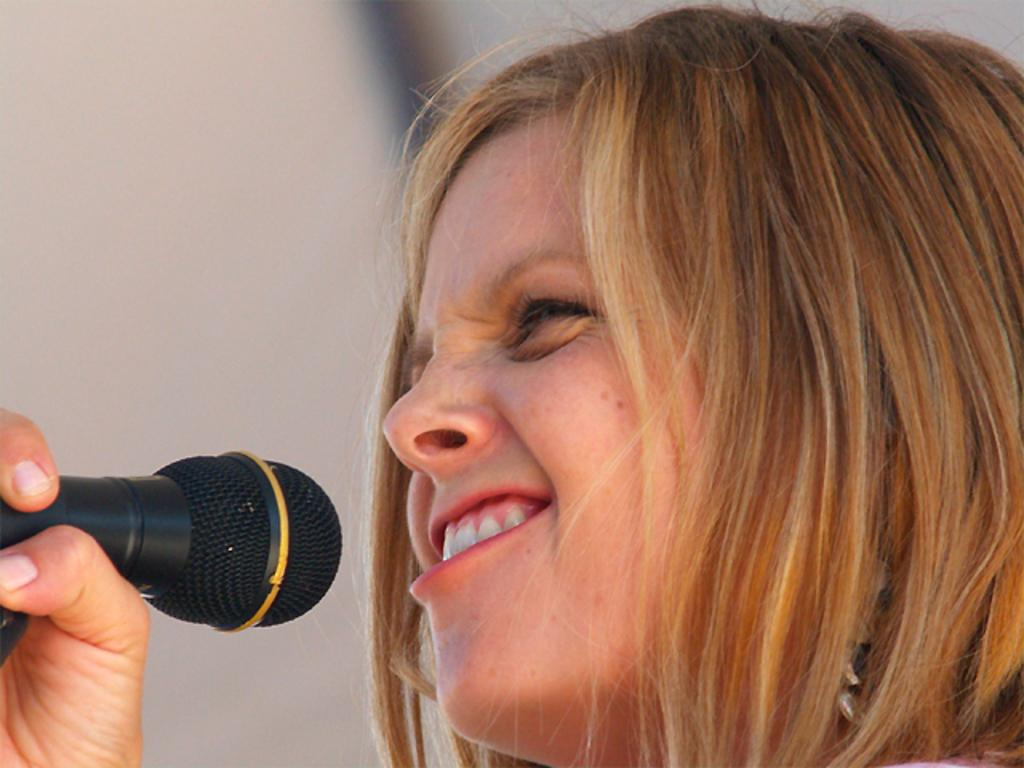What is the woman holding in the image? The woman is holding a mic. Can you describe the background of the image? The background of the image is blurred. What type of bag is the woman carrying in the image? There is no bag visible in the image; the woman is holding a mic. What amusement park is the woman performing at in the image? The image does not depict an amusement park, nor is there any indication of a performance taking place. 